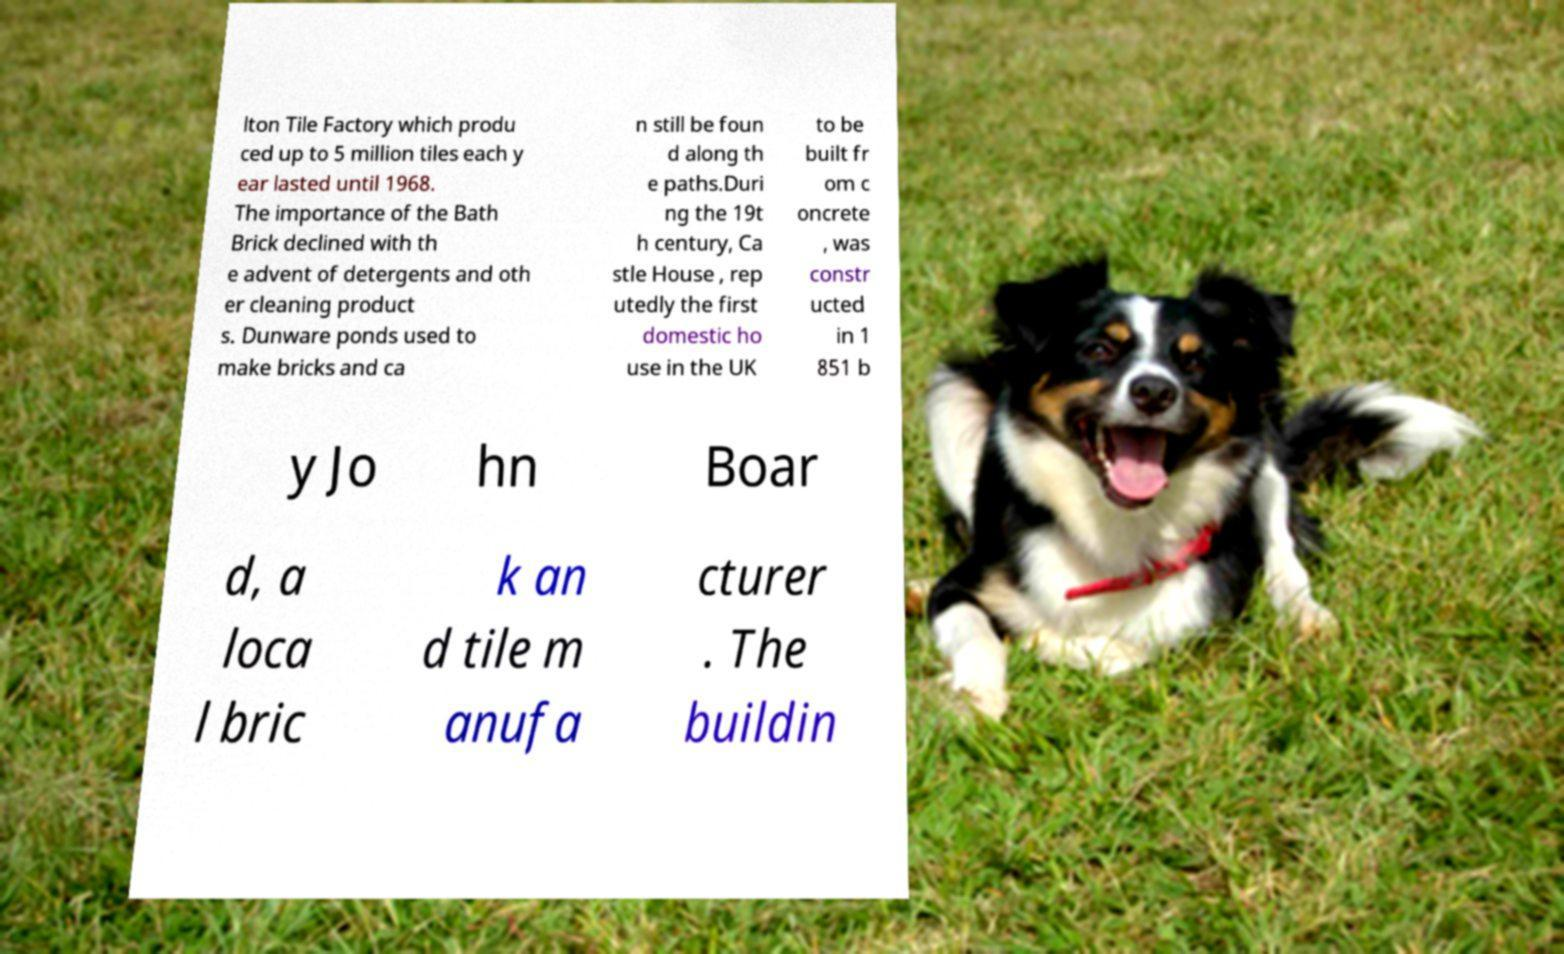Can you read and provide the text displayed in the image?This photo seems to have some interesting text. Can you extract and type it out for me? lton Tile Factory which produ ced up to 5 million tiles each y ear lasted until 1968. The importance of the Bath Brick declined with th e advent of detergents and oth er cleaning product s. Dunware ponds used to make bricks and ca n still be foun d along th e paths.Duri ng the 19t h century, Ca stle House , rep utedly the first domestic ho use in the UK to be built fr om c oncrete , was constr ucted in 1 851 b y Jo hn Boar d, a loca l bric k an d tile m anufa cturer . The buildin 